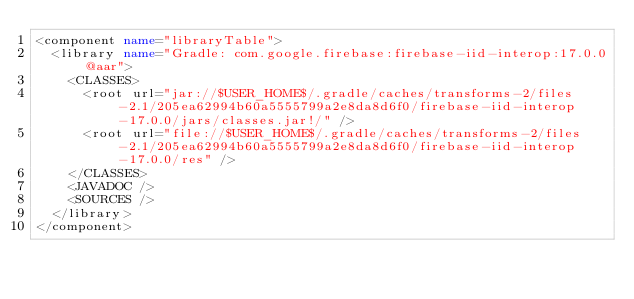Convert code to text. <code><loc_0><loc_0><loc_500><loc_500><_XML_><component name="libraryTable">
  <library name="Gradle: com.google.firebase:firebase-iid-interop:17.0.0@aar">
    <CLASSES>
      <root url="jar://$USER_HOME$/.gradle/caches/transforms-2/files-2.1/205ea62994b60a5555799a2e8da8d6f0/firebase-iid-interop-17.0.0/jars/classes.jar!/" />
      <root url="file://$USER_HOME$/.gradle/caches/transforms-2/files-2.1/205ea62994b60a5555799a2e8da8d6f0/firebase-iid-interop-17.0.0/res" />
    </CLASSES>
    <JAVADOC />
    <SOURCES />
  </library>
</component></code> 